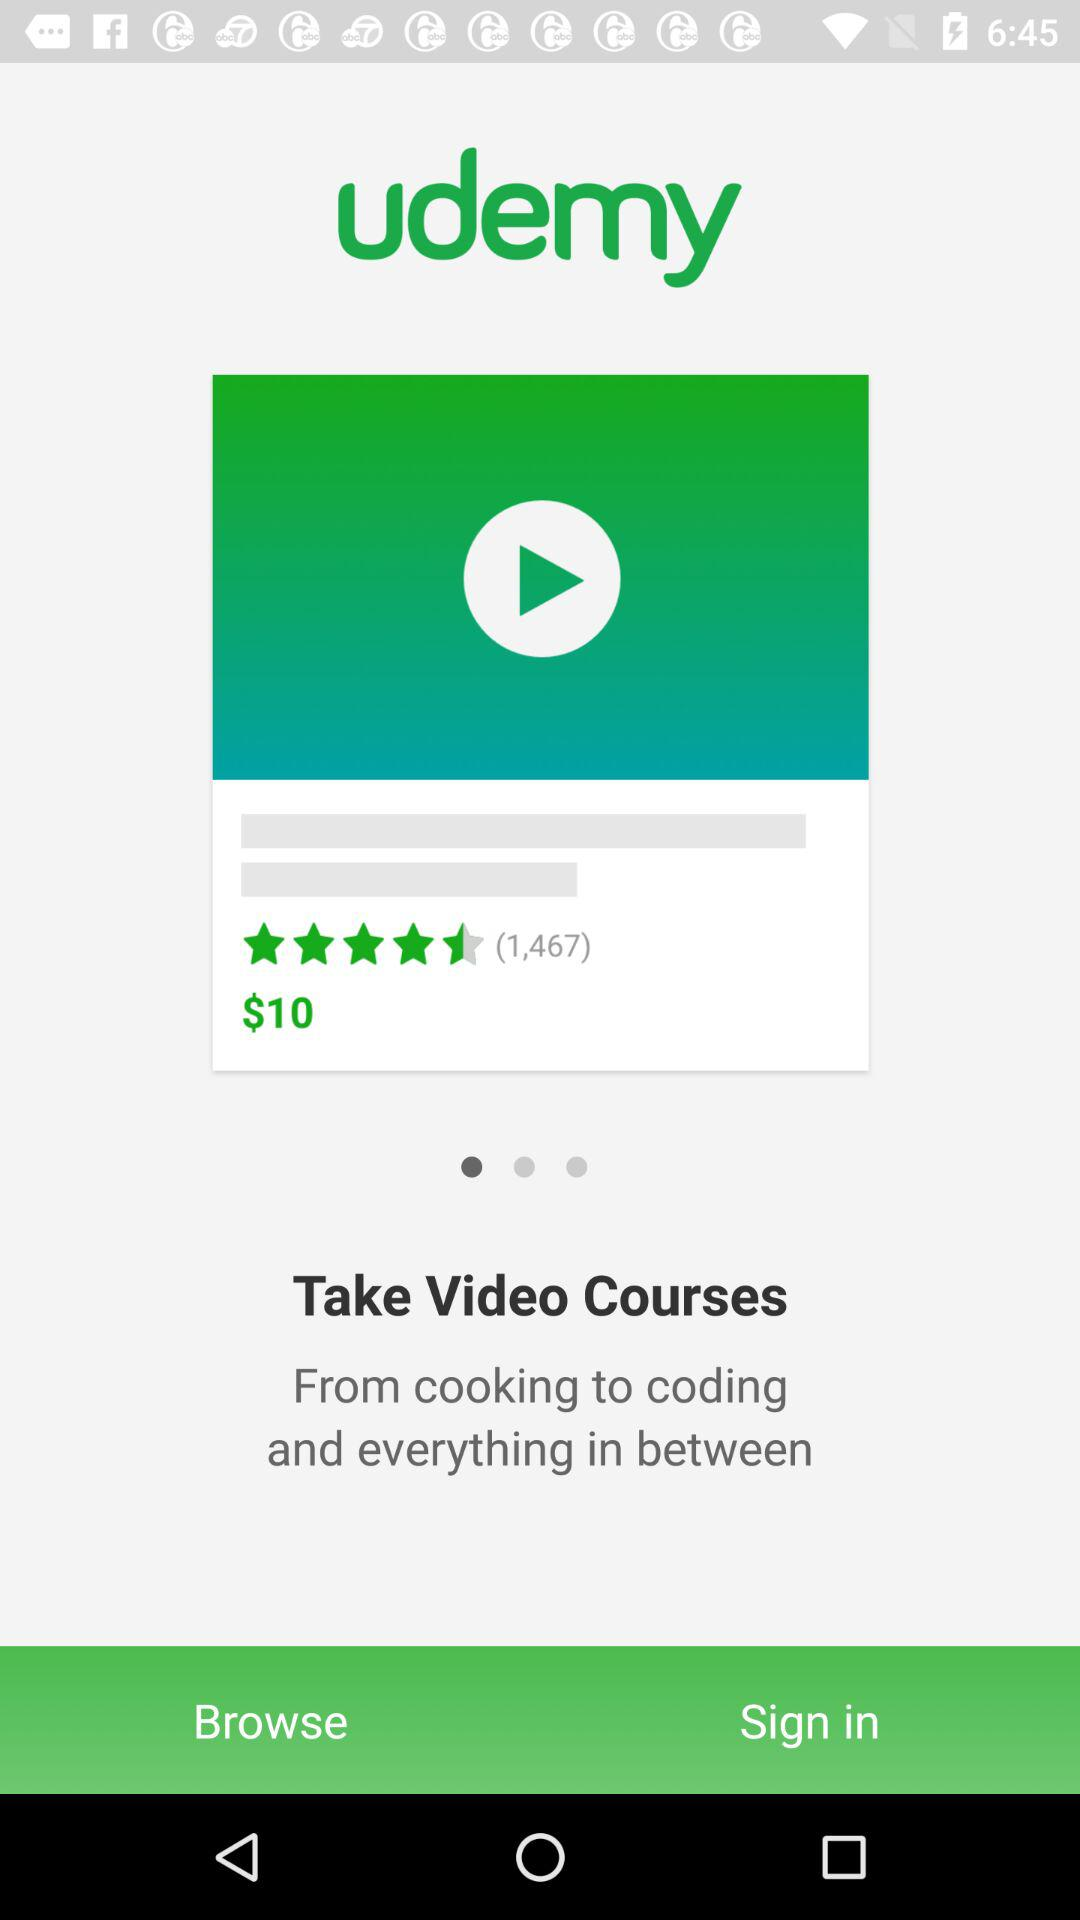What is the rating? The rating is 4.2 stars. 